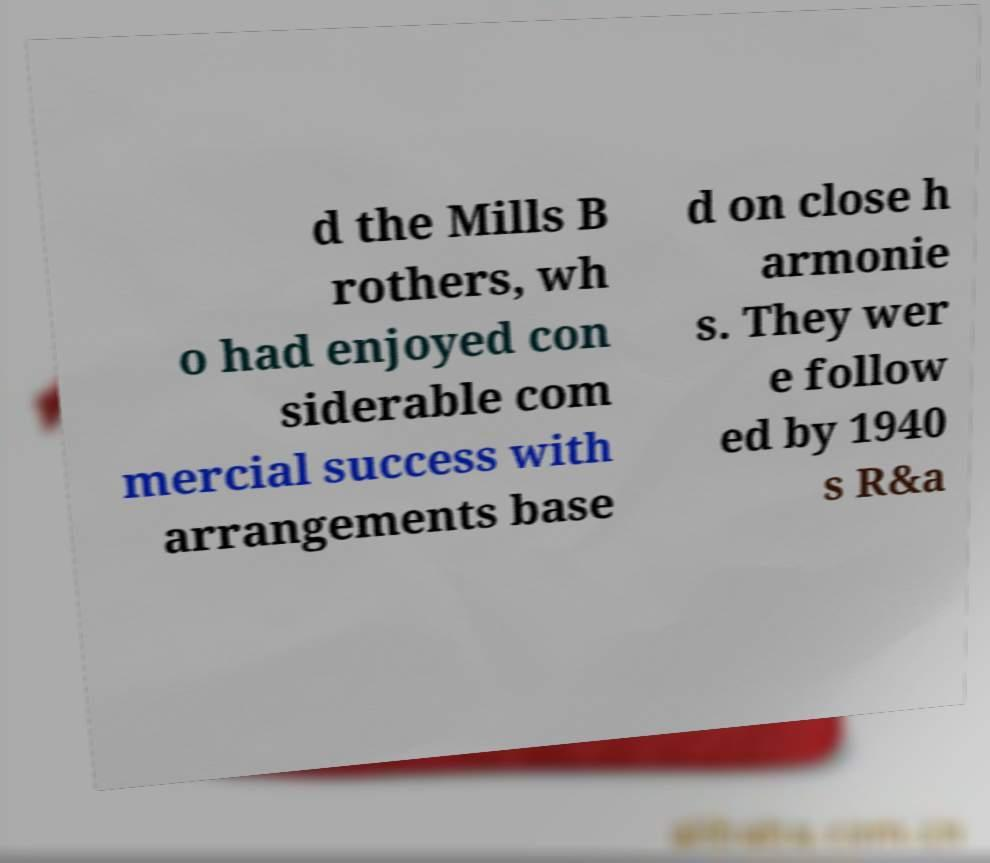What messages or text are displayed in this image? I need them in a readable, typed format. d the Mills B rothers, wh o had enjoyed con siderable com mercial success with arrangements base d on close h armonie s. They wer e follow ed by 1940 s R&a 